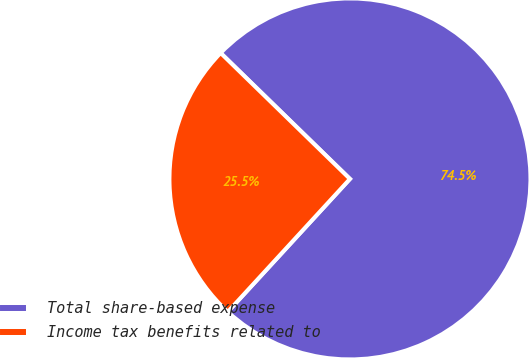Convert chart. <chart><loc_0><loc_0><loc_500><loc_500><pie_chart><fcel>Total share-based expense<fcel>Income tax benefits related to<nl><fcel>74.54%<fcel>25.46%<nl></chart> 